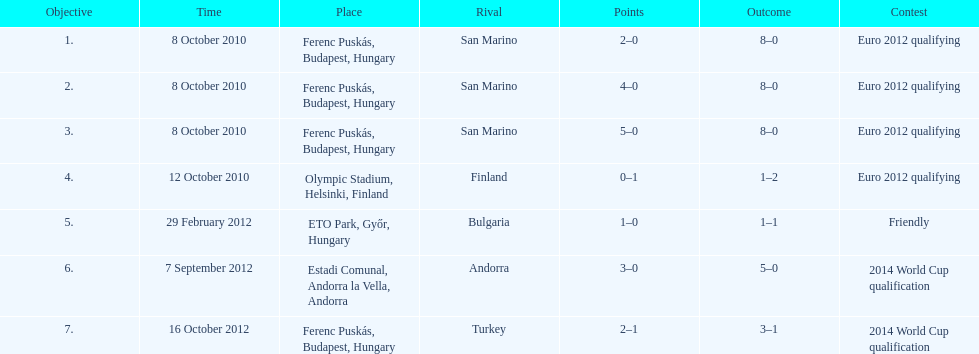What is the number of goals ádám szalai made against san marino in 2010? 3. 